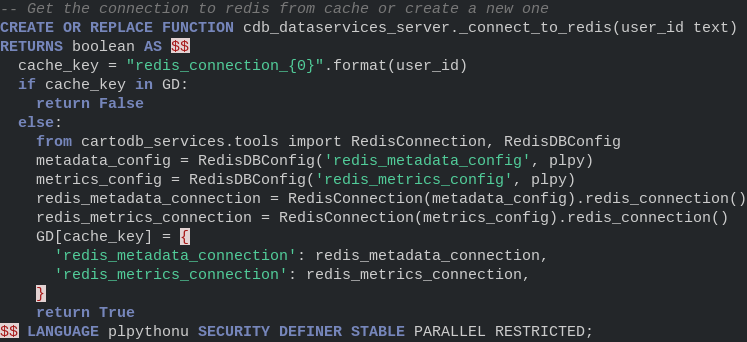Convert code to text. <code><loc_0><loc_0><loc_500><loc_500><_SQL_>-- Get the connection to redis from cache or create a new one
CREATE OR REPLACE FUNCTION cdb_dataservices_server._connect_to_redis(user_id text)
RETURNS boolean AS $$
  cache_key = "redis_connection_{0}".format(user_id)
  if cache_key in GD:
    return False
  else:
    from cartodb_services.tools import RedisConnection, RedisDBConfig
    metadata_config = RedisDBConfig('redis_metadata_config', plpy)
    metrics_config = RedisDBConfig('redis_metrics_config', plpy)
    redis_metadata_connection = RedisConnection(metadata_config).redis_connection()
    redis_metrics_connection = RedisConnection(metrics_config).redis_connection()
    GD[cache_key] = {
      'redis_metadata_connection': redis_metadata_connection,
      'redis_metrics_connection': redis_metrics_connection,
    }
    return True
$$ LANGUAGE plpythonu SECURITY DEFINER STABLE PARALLEL RESTRICTED;
</code> 